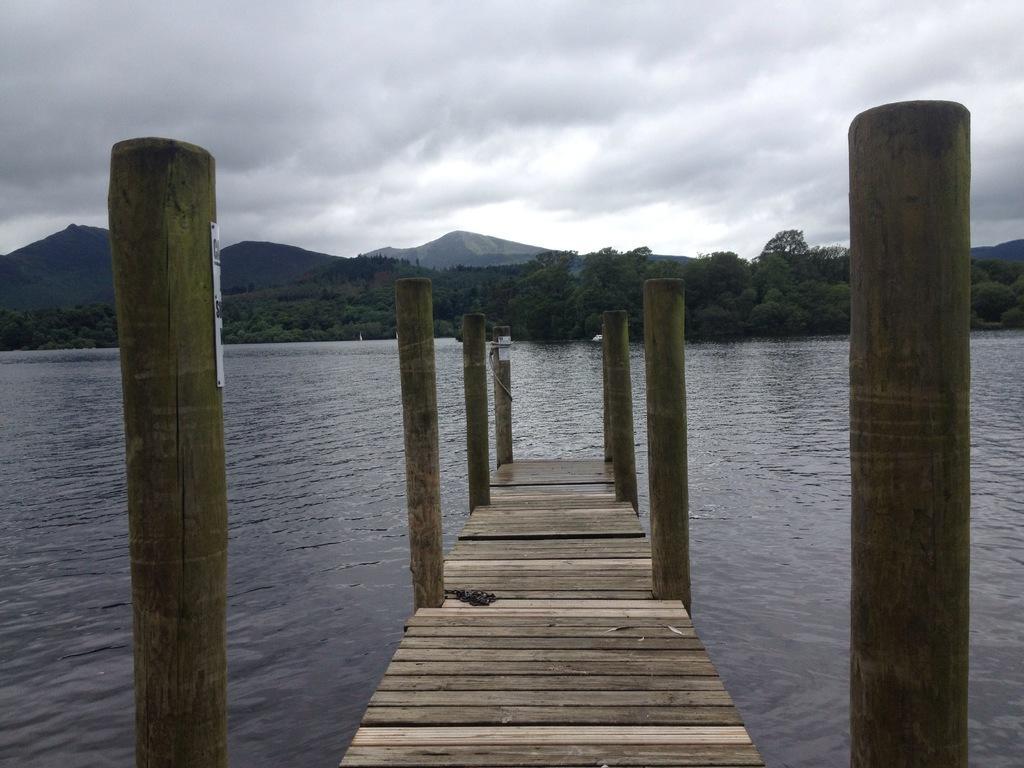Describe this image in one or two sentences. In the center of the picture there is the dock. In the foreground there is a water body. In the center of the picture there are trees and hills. Sky is cloudy. 